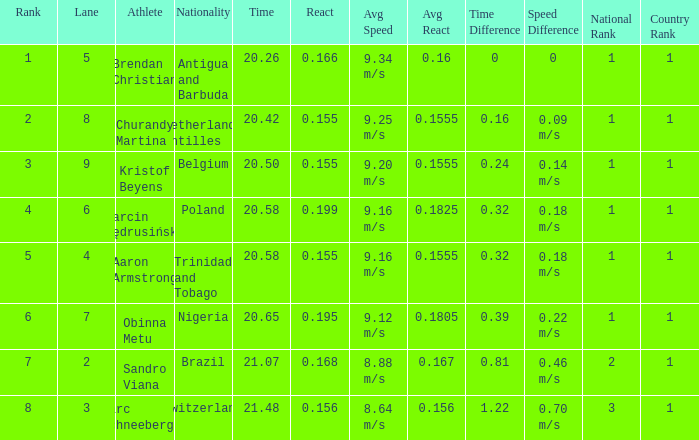Which Lane has a Time larger than 20.5, and a Nationality of trinidad and tobago? 4.0. 